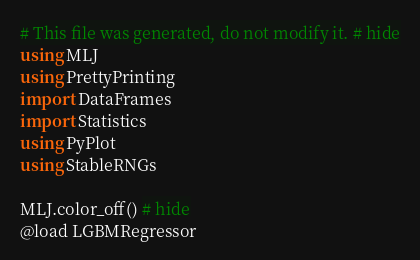<code> <loc_0><loc_0><loc_500><loc_500><_Julia_># This file was generated, do not modify it. # hide
using MLJ
using PrettyPrinting
import DataFrames
import Statistics
using PyPlot
using StableRNGs

MLJ.color_off() # hide
@load LGBMRegressor</code> 